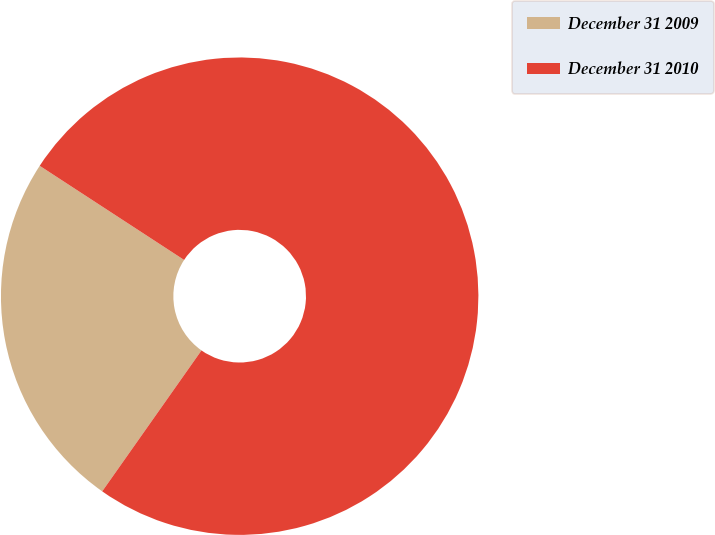Convert chart. <chart><loc_0><loc_0><loc_500><loc_500><pie_chart><fcel>December 31 2009<fcel>December 31 2010<nl><fcel>24.43%<fcel>75.57%<nl></chart> 